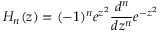<formula> <loc_0><loc_0><loc_500><loc_500>H _ { n } ( z ) = ( - 1 ) ^ { n } e ^ { z ^ { 2 } } \frac { d ^ { n } } { d z ^ { n } } e ^ { - z ^ { 2 } }</formula> 